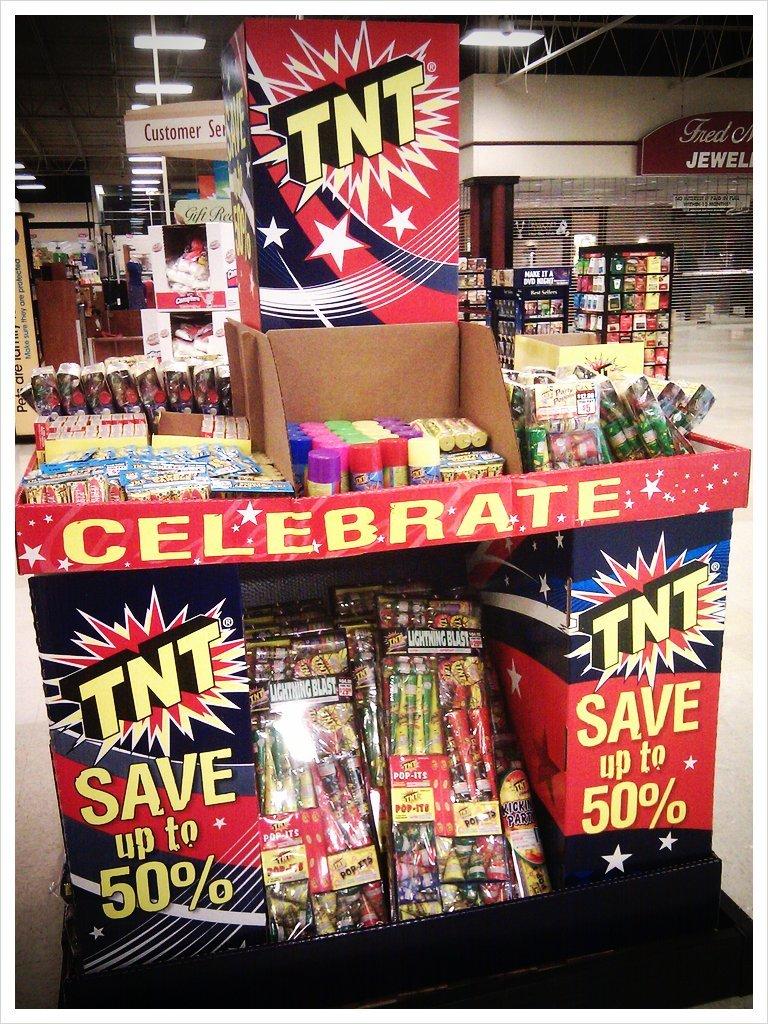What do the black letters say?
Ensure brevity in your answer.  Tnt. How much can you save up to?
Your answer should be very brief. 50%. 